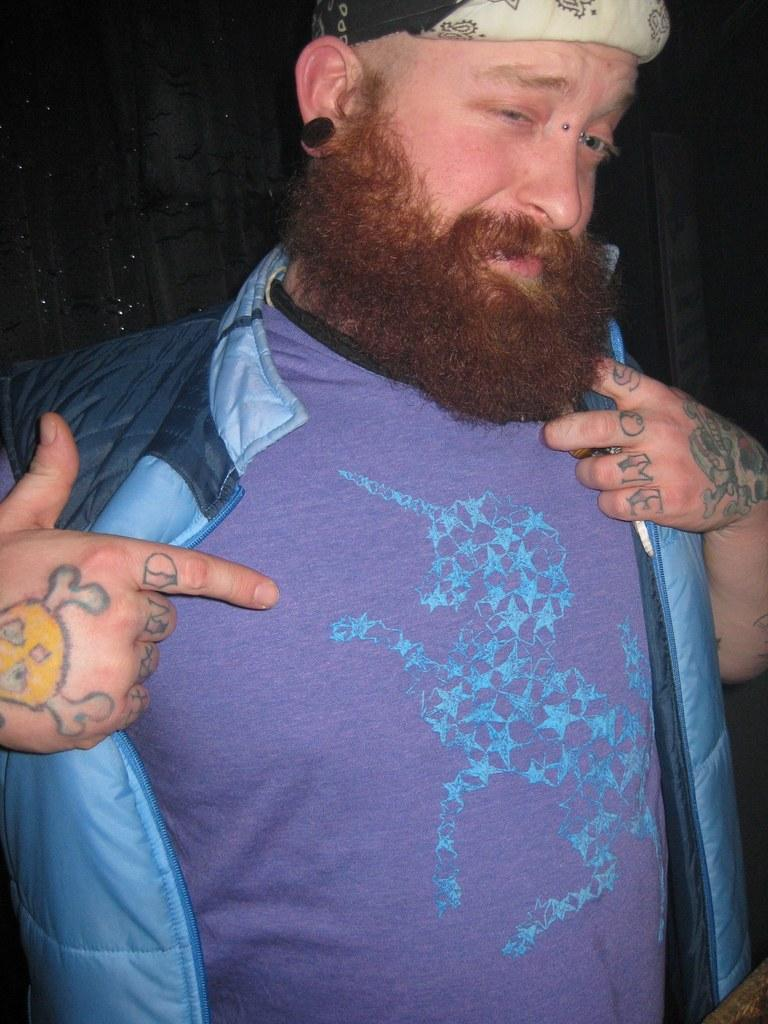What is present in the image? There is a person in the image. Can you describe what the person is wearing? The person is wearing a jacket. What type of sail can be seen in the image? There is no sail present in the image. Is there a cart visible in the image? No, there is no cart visible in the image. Can you see an apple in the image? No, there is no apple visible in the image. 